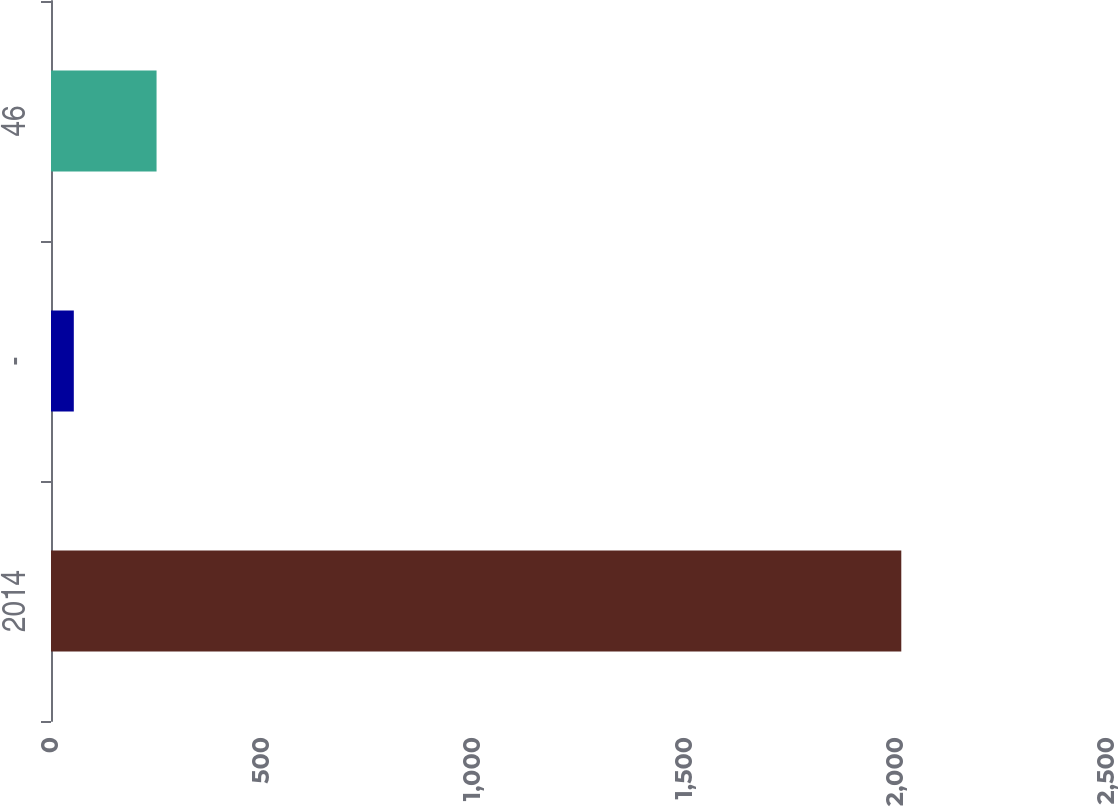<chart> <loc_0><loc_0><loc_500><loc_500><bar_chart><fcel>2014<fcel>-<fcel>46<nl><fcel>2013<fcel>54<fcel>249.9<nl></chart> 